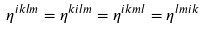<formula> <loc_0><loc_0><loc_500><loc_500>\eta ^ { i k l m } = \eta ^ { k i l m } = \eta ^ { i k m l } = \eta ^ { l m i k }</formula> 